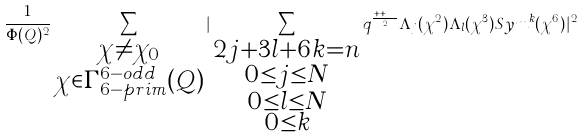Convert formula to latex. <formula><loc_0><loc_0><loc_500><loc_500>\frac { 1 } { \Phi ( Q ) ^ { 2 } } \sum _ { \substack { \chi \neq \chi _ { 0 } \\ \chi \in \Gamma _ { 6 - p r i m } ^ { 6 - o d d } ( Q ) } } | \sum _ { \substack { 2 j + 3 l + 6 k = n \\ 0 \leq j \leq N \\ 0 \leq l \leq N \\ 0 \leq k } } q ^ { \frac { j + k + l } { 2 } } \Lambda _ { j } ( \chi ^ { 2 } ) \Lambda _ { l } ( \chi ^ { 3 } ) S y m ^ { k } ( \chi ^ { 6 } ) | ^ { 2 }</formula> 